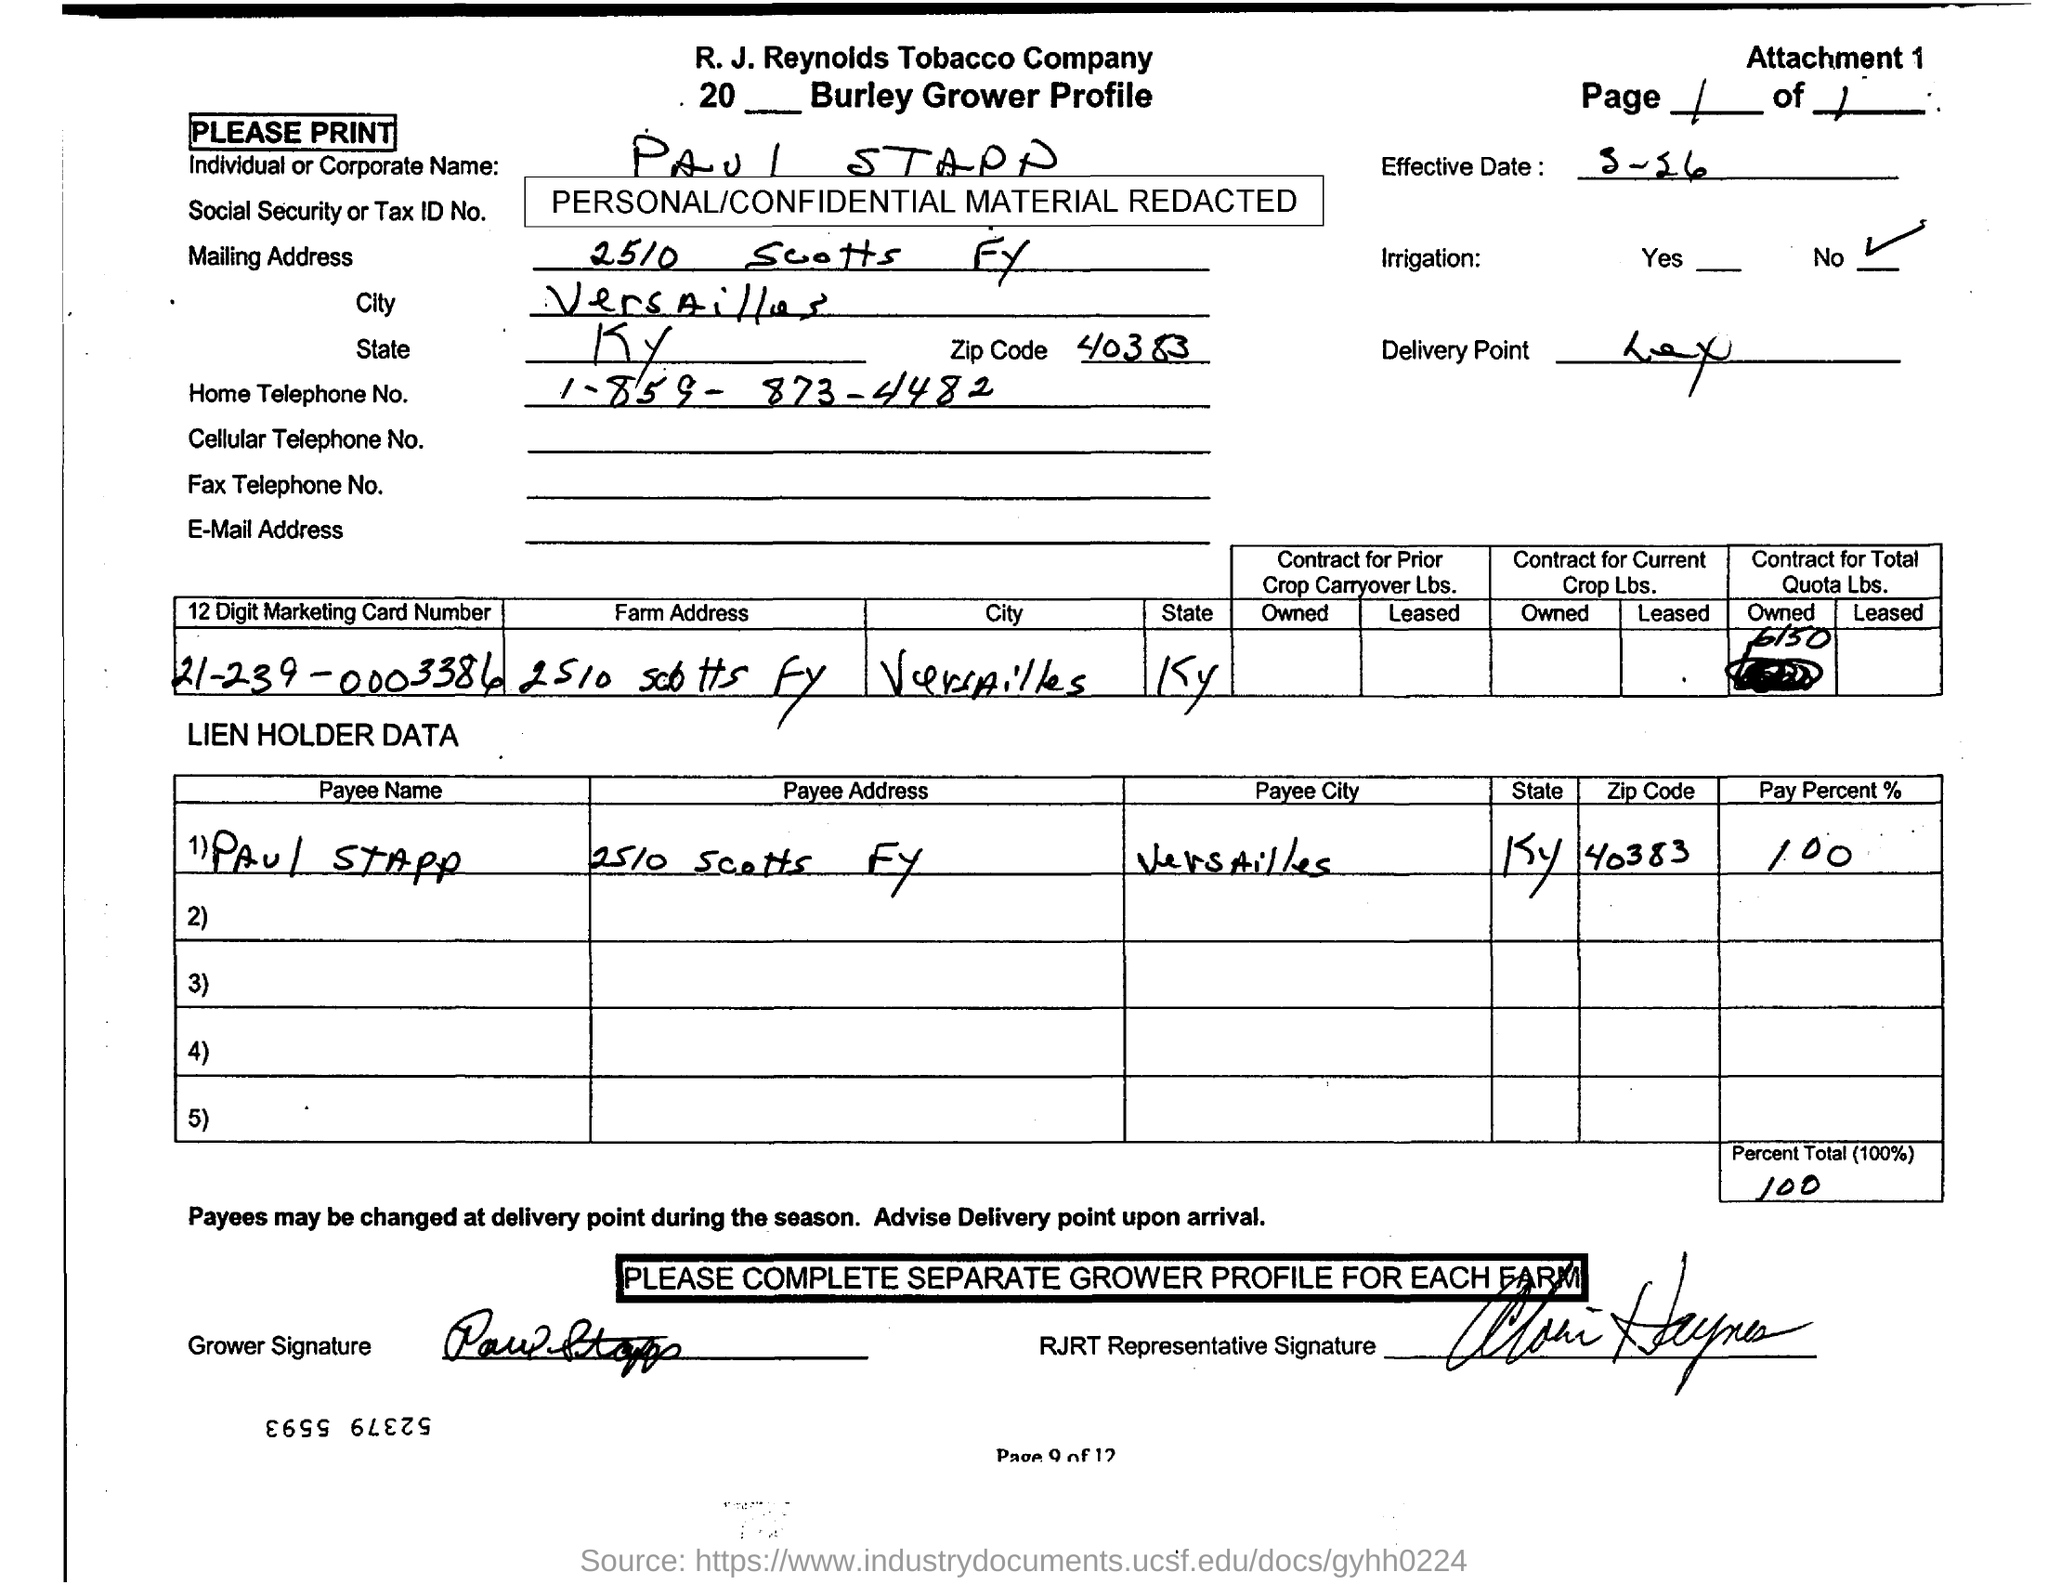Identify some key points in this picture. The pay percent stated in the document is 100. The payee's name listed in the document is "Paul Stapp. I, [name], request the home telephone number of Paul Stapp, which is 1-859-873-4482. The payee address mentioned in the document is "2510 Scotts FY..". The zipcode referenced in this document is 40383.. 